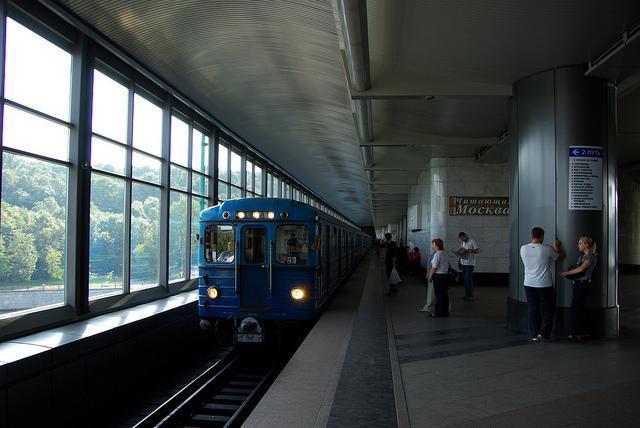How many people are in the picture?
Give a very brief answer. 2. How many rolls of toilet  paper?
Give a very brief answer. 0. 